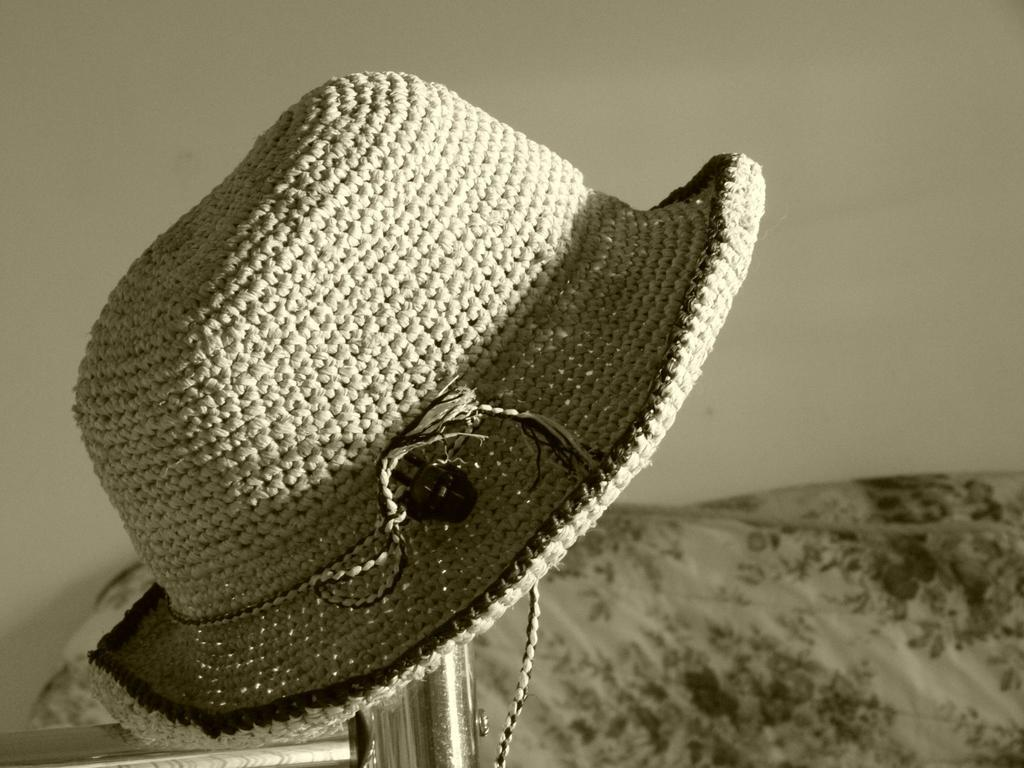What object can be seen in the image? There is a hat in the image. What is visible in the background of the image? There is a wall in the background of the image. How would you describe the color scheme of the image? The image is black and white. What is the price of the hat in the image? There is no price mentioned or visible in the image, as it is a black and white photograph. 